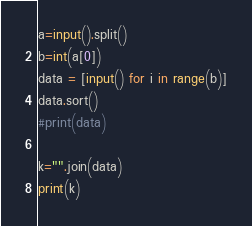<code> <loc_0><loc_0><loc_500><loc_500><_Python_>a=input().split()
b=int(a[0])
data = [input() for i in range(b)]
data.sort()
#print(data)

k="".join(data)
print(k)</code> 